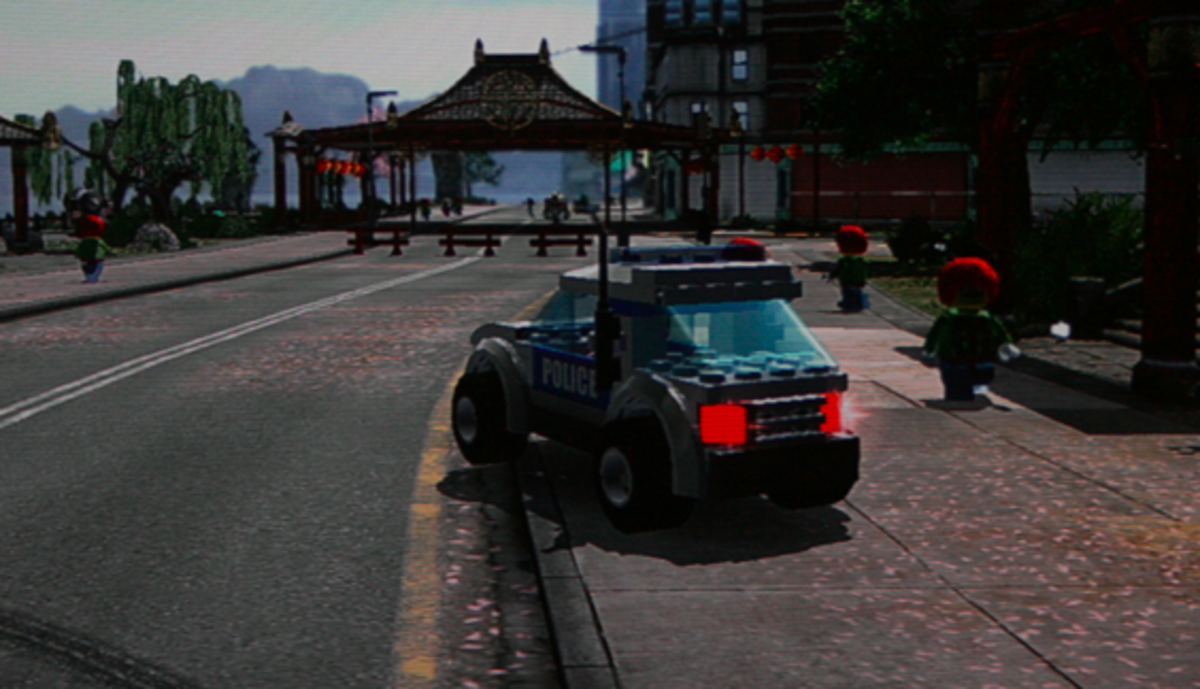What details in the image suggest that the game emphasizes creativity and exploration? The image showcases a police vehicle constructed from building blocks which indicates a customizable aspect to the vehicles within the game. The open street scene with various characters moving about suggests a non-linear, explorative approach to gameplay. This setting allows players to freely navigate and interact with the world, hinting at endless possibilities for creativity and exploration as elements can likely be built or modified according to the player's preference. 